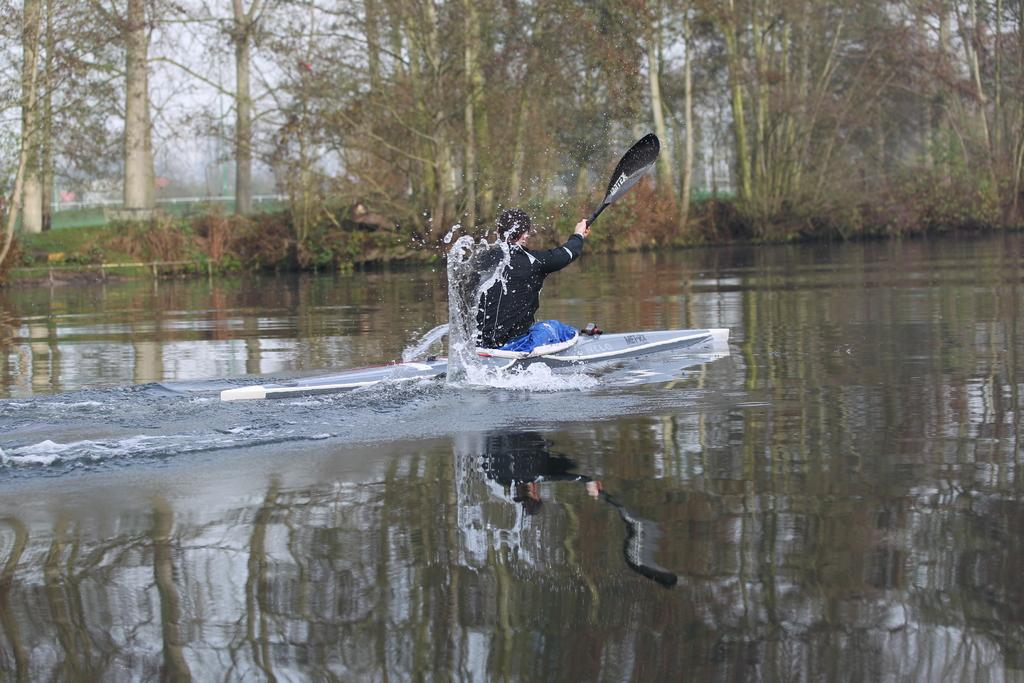What is the person in the image doing? The person is paddling in the water. What can be seen in the background of the image? There are trees and plants in the image. What type of hobbies does the cannon in the image enjoy? There is no cannon present in the image, so we cannot discuss its hobbies. 